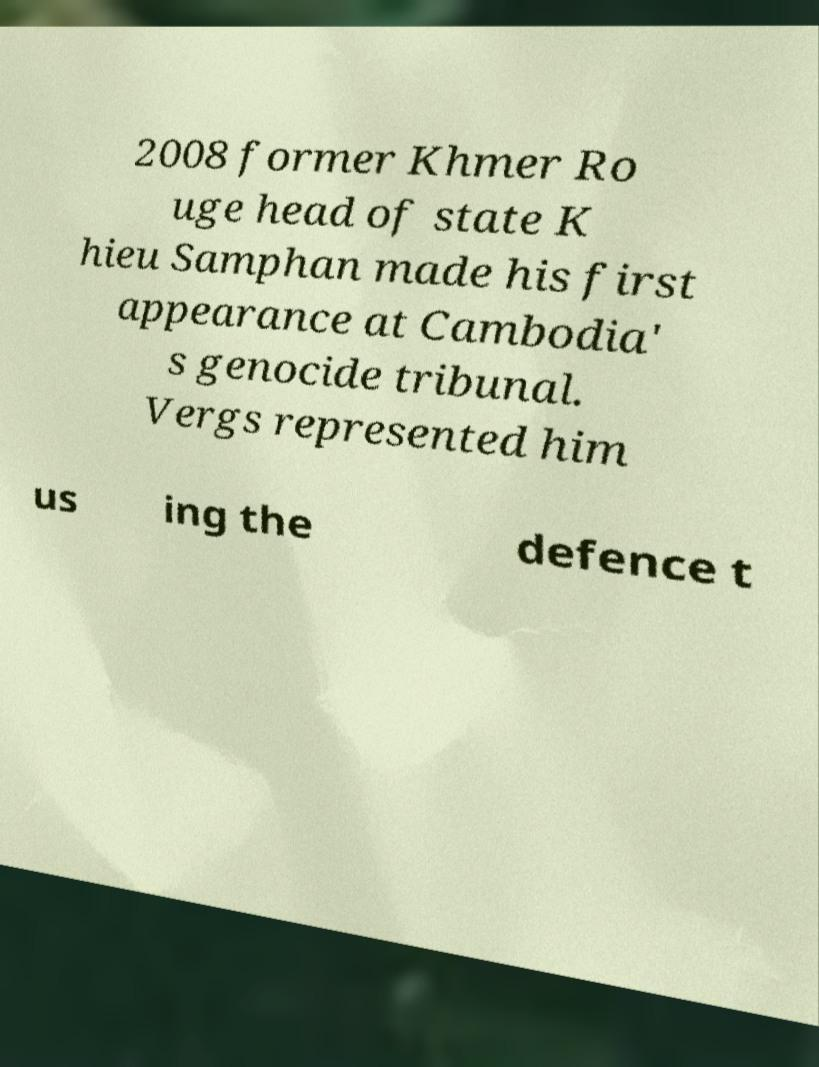For documentation purposes, I need the text within this image transcribed. Could you provide that? 2008 former Khmer Ro uge head of state K hieu Samphan made his first appearance at Cambodia' s genocide tribunal. Vergs represented him us ing the defence t 